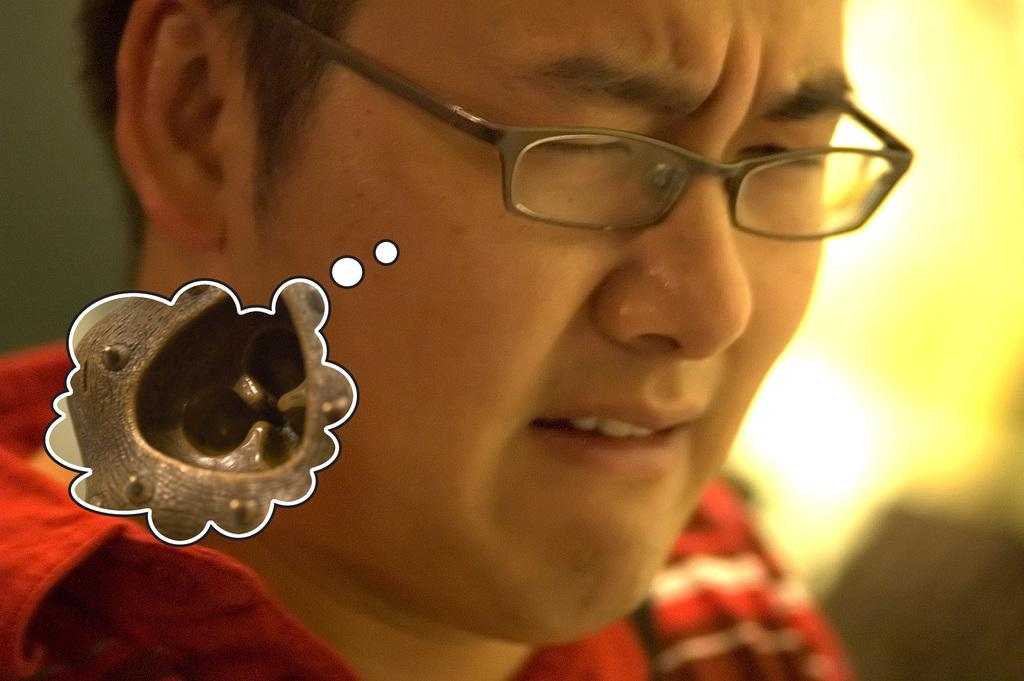What is present in the image? There is a person in the image. Can you describe the person's appearance? The person is wearing spectacles. What other object can be seen in the image? There is a cloud-shaped object in the image. What type of wine is being served in the image? There is no wine present in the image; it only features a person wearing spectacles and a cloud-shaped object. 